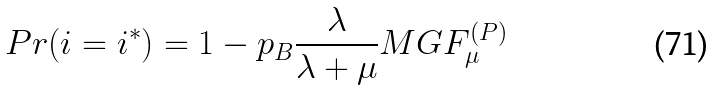Convert formula to latex. <formula><loc_0><loc_0><loc_500><loc_500>P r ( i = i ^ { * } ) & = 1 - p _ { B } \frac { \lambda } { \lambda + \mu } M G F _ { \mu } ^ { ( P ) }</formula> 